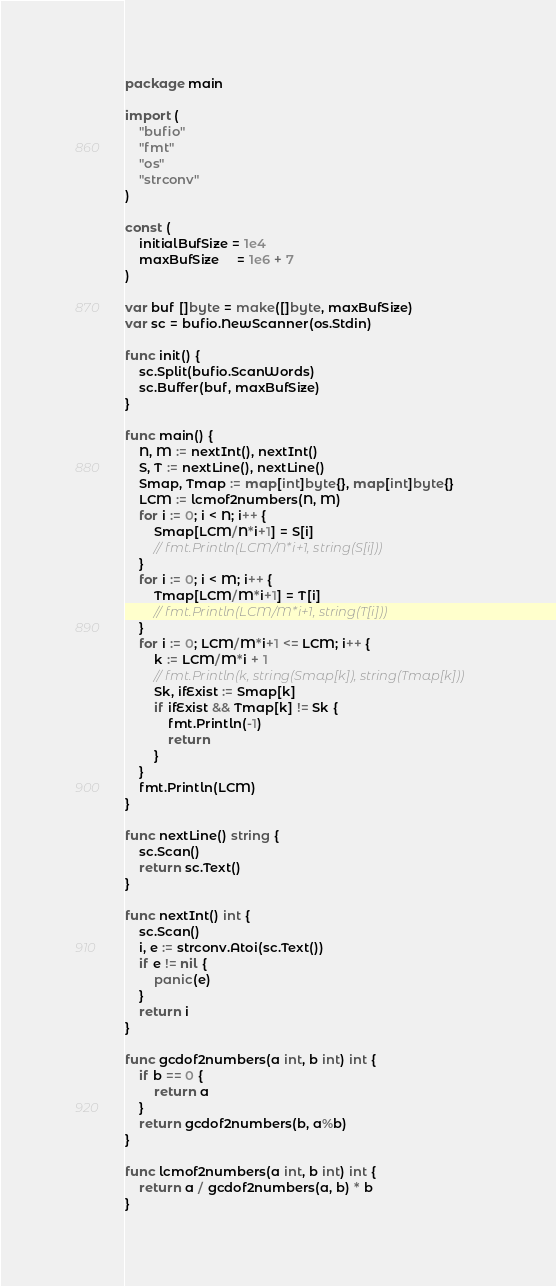<code> <loc_0><loc_0><loc_500><loc_500><_Go_>package main

import (
	"bufio"
	"fmt"
	"os"
	"strconv"
)

const (
	initialBufSize = 1e4
	maxBufSize     = 1e6 + 7
)

var buf []byte = make([]byte, maxBufSize)
var sc = bufio.NewScanner(os.Stdin)

func init() {
	sc.Split(bufio.ScanWords)
	sc.Buffer(buf, maxBufSize)
}

func main() {
	N, M := nextInt(), nextInt()
	S, T := nextLine(), nextLine()
	Smap, Tmap := map[int]byte{}, map[int]byte{}
	LCM := lcmof2numbers(N, M)
	for i := 0; i < N; i++ {
		Smap[LCM/N*i+1] = S[i]
		// fmt.Println(LCM/N*i+1, string(S[i]))
	}
	for i := 0; i < M; i++ {
		Tmap[LCM/M*i+1] = T[i]
		// fmt.Println(LCM/M*i+1, string(T[i]))
	}
	for i := 0; LCM/M*i+1 <= LCM; i++ {
		k := LCM/M*i + 1
		// fmt.Println(k, string(Smap[k]), string(Tmap[k]))
		Sk, ifExist := Smap[k]
		if ifExist && Tmap[k] != Sk {
			fmt.Println(-1)
			return
		}
	}
	fmt.Println(LCM)
}

func nextLine() string {
	sc.Scan()
	return sc.Text()
}

func nextInt() int {
	sc.Scan()
	i, e := strconv.Atoi(sc.Text())
	if e != nil {
		panic(e)
	}
	return i
}

func gcdof2numbers(a int, b int) int {
	if b == 0 {
		return a
	}
	return gcdof2numbers(b, a%b)
}

func lcmof2numbers(a int, b int) int {
	return a / gcdof2numbers(a, b) * b
}
</code> 